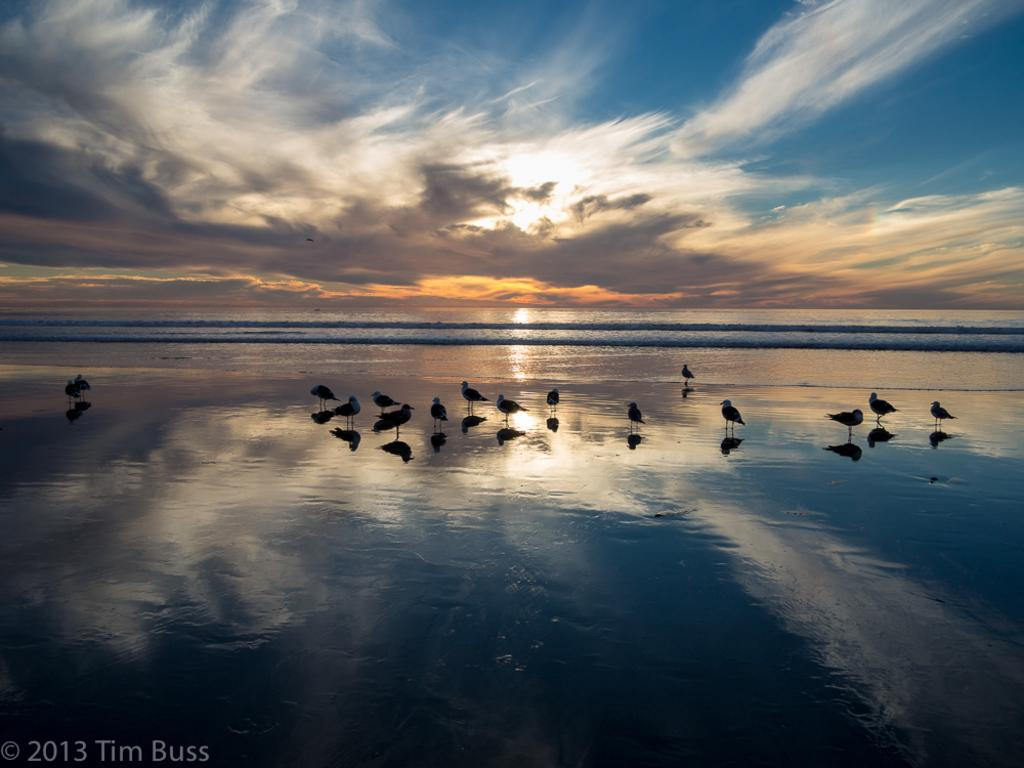What can be seen on the beach in the image? There are flocks of birds on the beach in the image. What else is visible in the image besides the birds? There is text visible in the image, as well as water and the sky in the background. What type of terrain is the beach likely to have? The image is likely taken on a sandy beach. What type of ornament is hanging from the spoon in the image? There is no spoon or ornament present in the image. How is the waste being managed on the beach in the image? The image does not show any waste management practices; it only depicts flocks of birds on the beach. 